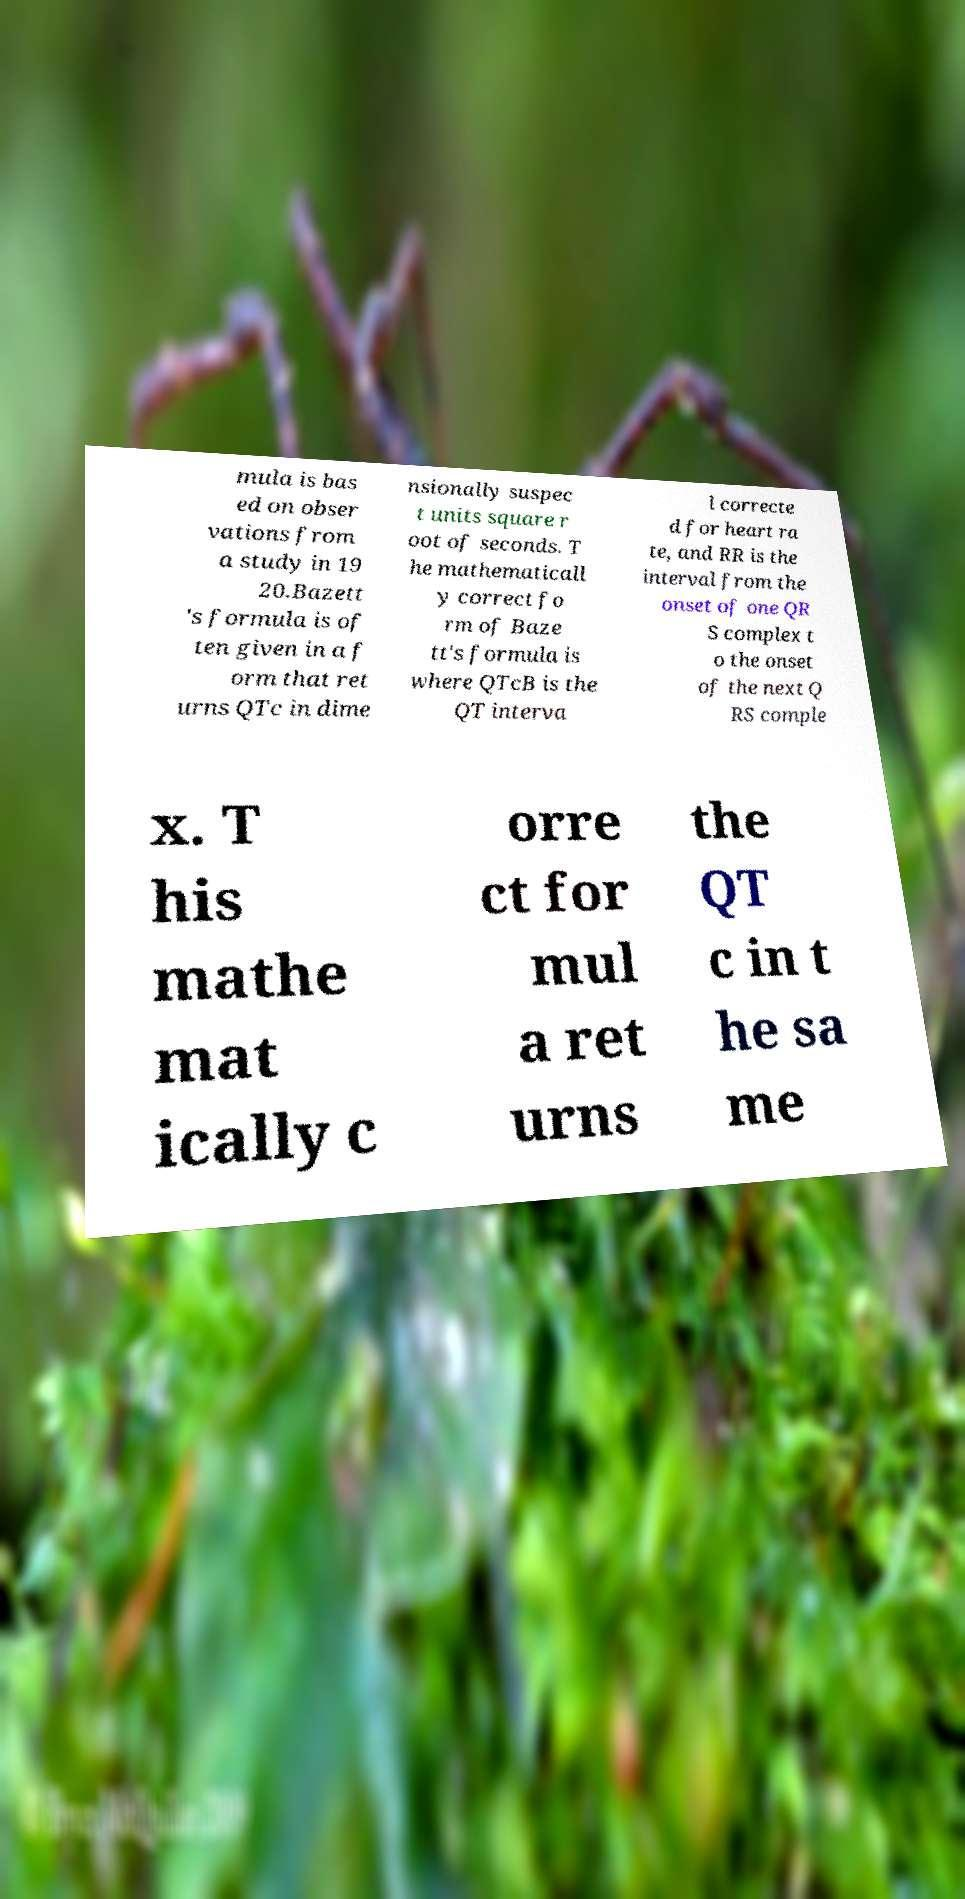Could you extract and type out the text from this image? mula is bas ed on obser vations from a study in 19 20.Bazett 's formula is of ten given in a f orm that ret urns QTc in dime nsionally suspec t units square r oot of seconds. T he mathematicall y correct fo rm of Baze tt's formula is where QTcB is the QT interva l correcte d for heart ra te, and RR is the interval from the onset of one QR S complex t o the onset of the next Q RS comple x. T his mathe mat ically c orre ct for mul a ret urns the QT c in t he sa me 